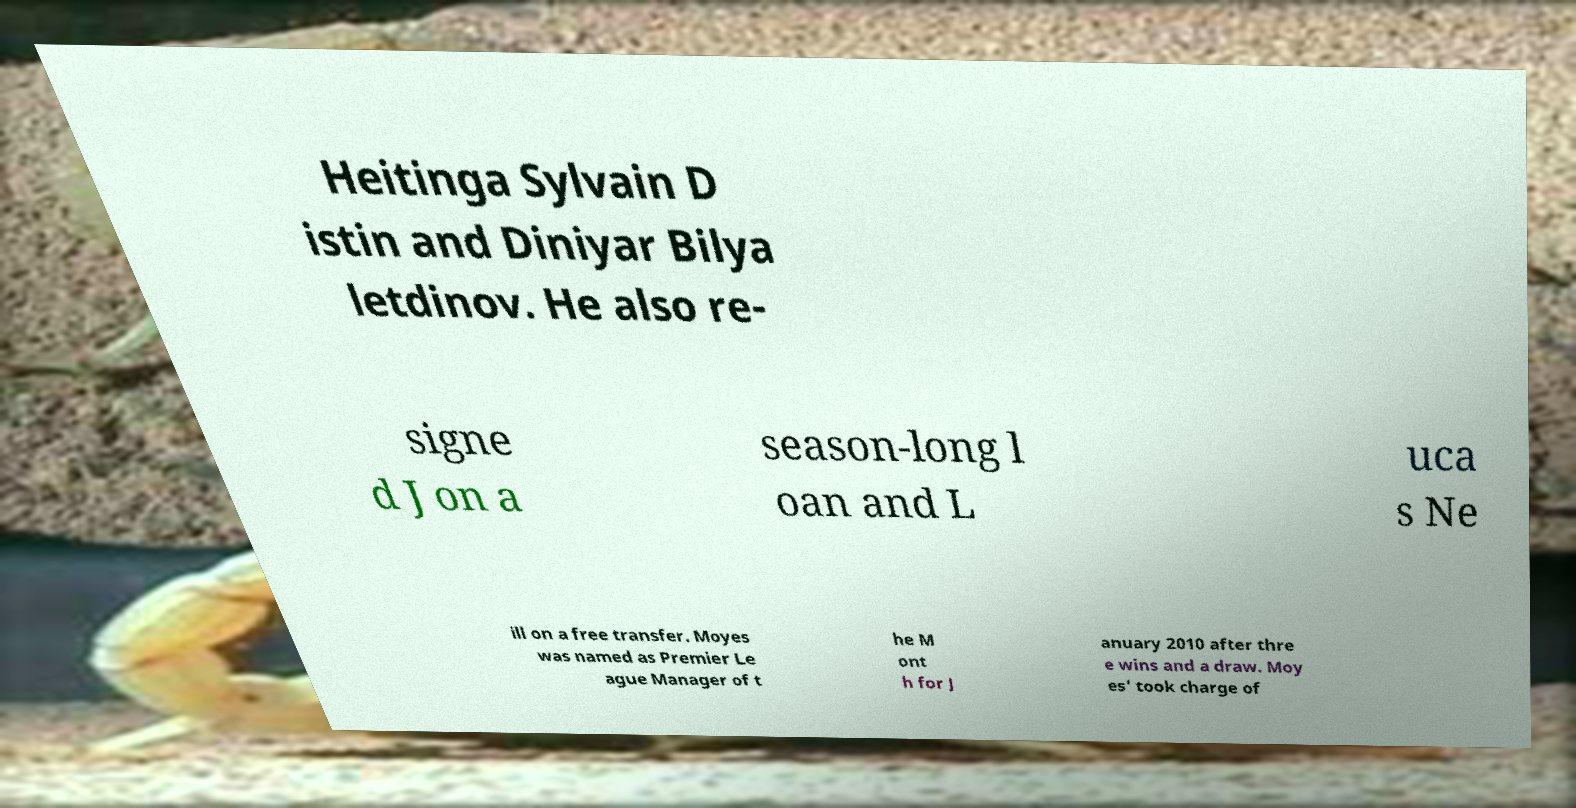Please read and relay the text visible in this image. What does it say? Heitinga Sylvain D istin and Diniyar Bilya letdinov. He also re- signe d J on a season-long l oan and L uca s Ne ill on a free transfer. Moyes was named as Premier Le ague Manager of t he M ont h for J anuary 2010 after thre e wins and a draw. Moy es' took charge of 